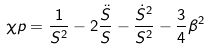Convert formula to latex. <formula><loc_0><loc_0><loc_500><loc_500>\chi p = \frac { 1 } { S ^ { 2 } } - 2 \frac { \ddot { S } } { S } - \frac { \dot { S } ^ { 2 } } { S ^ { 2 } } - \frac { 3 } { 4 } \beta ^ { 2 }</formula> 